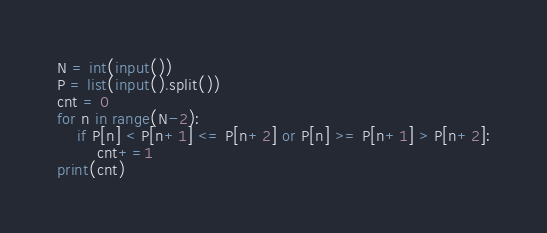<code> <loc_0><loc_0><loc_500><loc_500><_Python_>N = int(input())
P = list(input().split())
cnt = 0
for n in range(N-2):
    if P[n] < P[n+1] <= P[n+2] or P[n] >= P[n+1] > P[n+2]:
        cnt+=1
print(cnt)</code> 